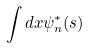<formula> <loc_0><loc_0><loc_500><loc_500>\int d x \psi _ { n } ^ { * } ( s )</formula> 